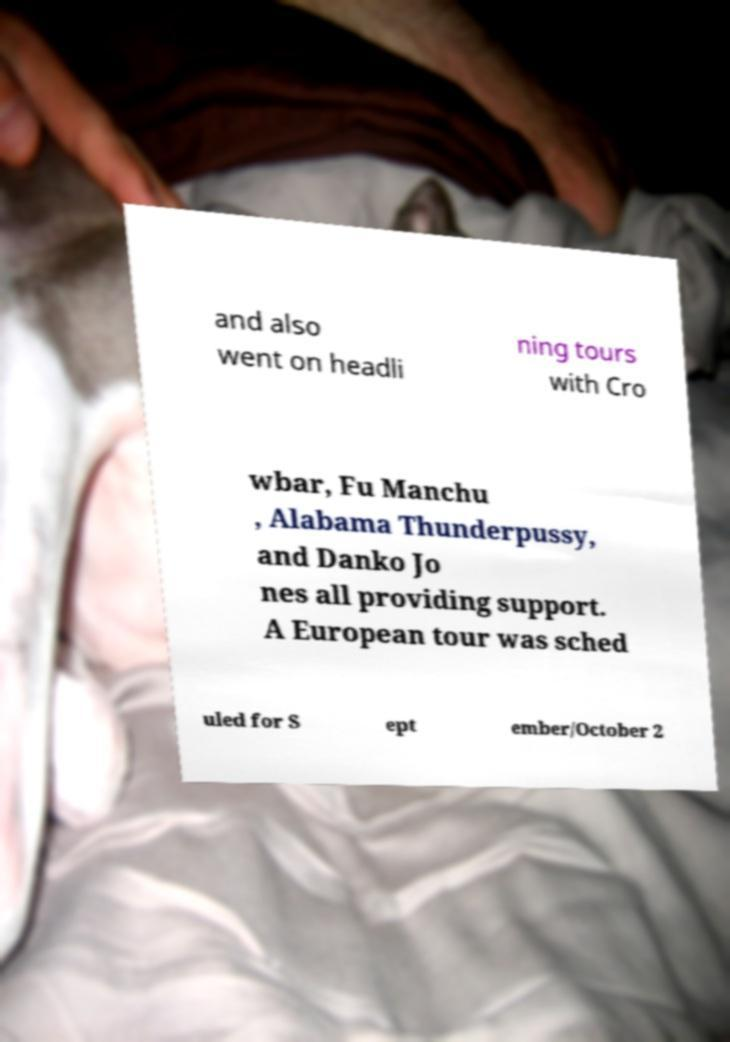What messages or text are displayed in this image? I need them in a readable, typed format. and also went on headli ning tours with Cro wbar, Fu Manchu , Alabama Thunderpussy, and Danko Jo nes all providing support. A European tour was sched uled for S ept ember/October 2 